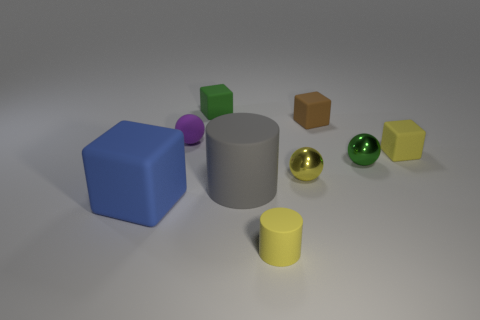What material is the yellow ball that is the same size as the green metal object?
Ensure brevity in your answer.  Metal. What number of other things are there of the same material as the yellow cube
Give a very brief answer. 6. Are there an equal number of gray objects that are behind the brown thing and green balls in front of the gray thing?
Your response must be concise. Yes. How many purple things are either small cubes or matte balls?
Provide a short and direct response. 1. Is the color of the large rubber cylinder the same as the rubber block that is on the left side of the tiny purple matte object?
Make the answer very short. No. How many other things are there of the same color as the small matte cylinder?
Keep it short and to the point. 2. Are there fewer green metallic things than big purple rubber things?
Provide a short and direct response. No. What number of yellow objects are left of the small yellow rubber object to the right of the tiny yellow object that is in front of the gray rubber cylinder?
Your answer should be very brief. 2. What size is the green thing behind the purple sphere?
Your answer should be compact. Small. There is a big object on the right side of the small matte ball; is it the same shape as the tiny yellow shiny object?
Make the answer very short. No. 